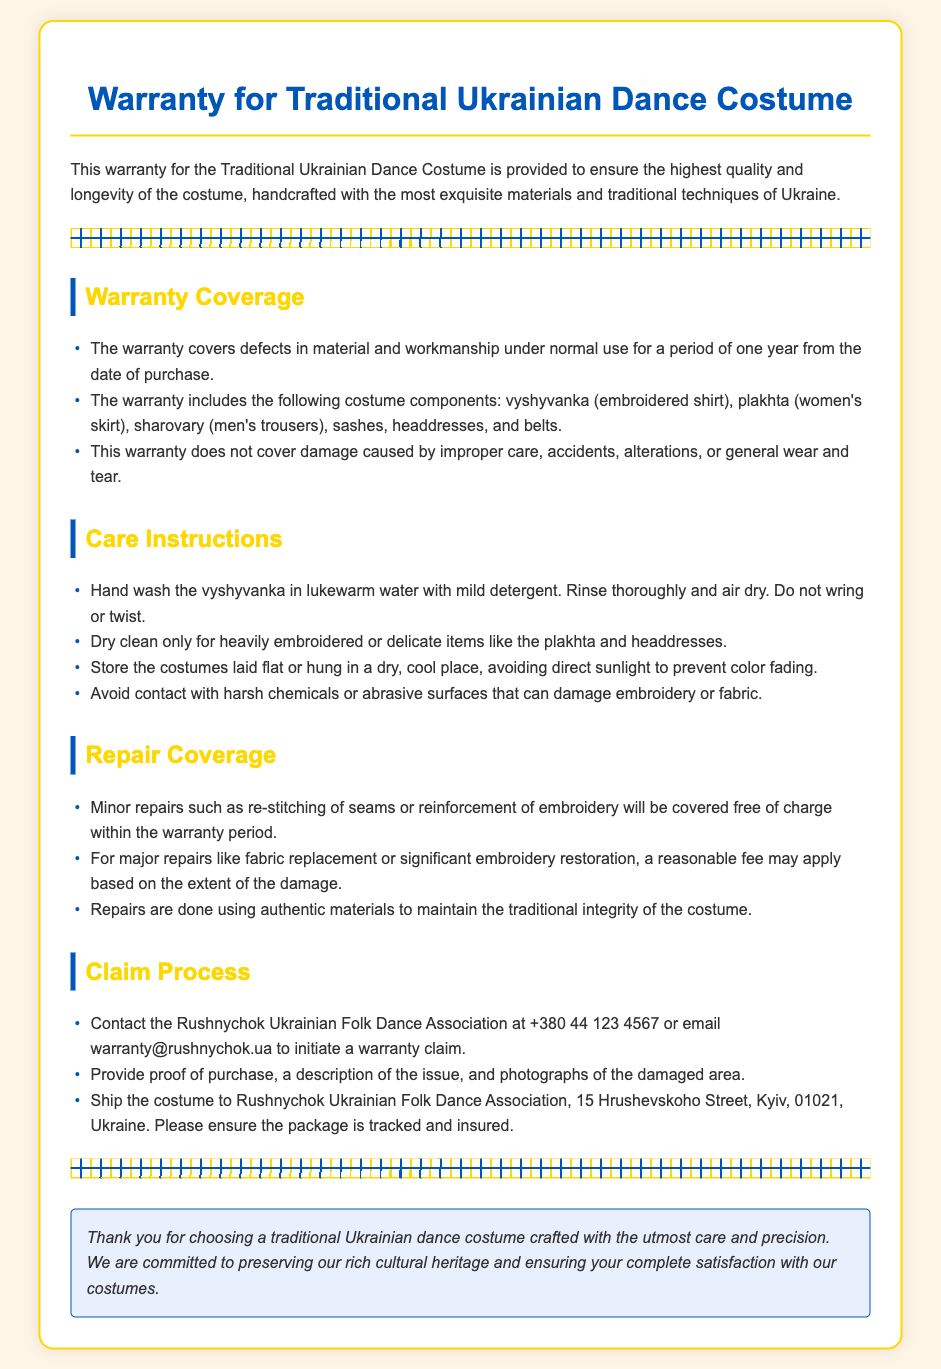What is the duration of the warranty? The warranty covers defects for a period of one year from the date of purchase.
Answer: one year Which costume components are included in the warranty? The listed components under warranty coverage include vyshyvanka, plakhta, sharovary, sashes, headdresses, and belts.
Answer: vyshyvanka, plakhta, sharovary, sashes, headdresses, belts What types of repairs are covered at no charge? The warranty covers minor repairs such as re-stitching of seams or reinforcement of embroidery free of charge within the warranty period.
Answer: minor repairs What should you do to initiate a warranty claim? To initiate a claim, contact the Rushnychok Ukrainian Folk Dance Association and provide necessary details including proof of purchase.
Answer: contact Rushnychok What method of cleaning is recommended for heavily embroidered items? For heavily embroidered or delicate items like plakhta and headdresses, dry cleaning is recommended.
Answer: dry clean only 